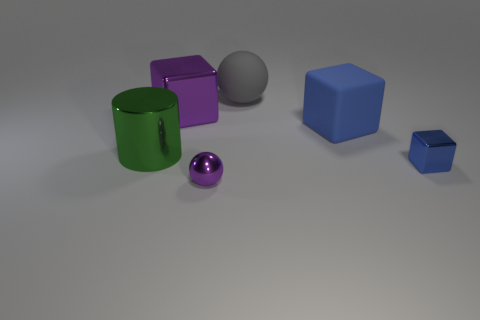The rubber cube that is the same size as the cylinder is what color?
Your answer should be very brief. Blue. Are there the same number of rubber spheres behind the large purple shiny thing and purple shiny spheres that are behind the gray sphere?
Offer a terse response. No. There is a purple thing behind the purple metal object that is in front of the large cylinder; what is it made of?
Ensure brevity in your answer.  Metal. How many things are either big purple things or large gray matte cubes?
Your answer should be very brief. 1. The rubber object that is the same color as the small metallic block is what size?
Your response must be concise. Large. Is the number of shiny things less than the number of purple matte balls?
Give a very brief answer. No. There is a blue thing that is the same material as the large gray object; what is its size?
Provide a succinct answer. Large. The gray ball is what size?
Provide a succinct answer. Large. The small blue object is what shape?
Offer a very short reply. Cube. Does the tiny metallic thing that is to the left of the large blue thing have the same color as the rubber cube?
Your answer should be very brief. No. 